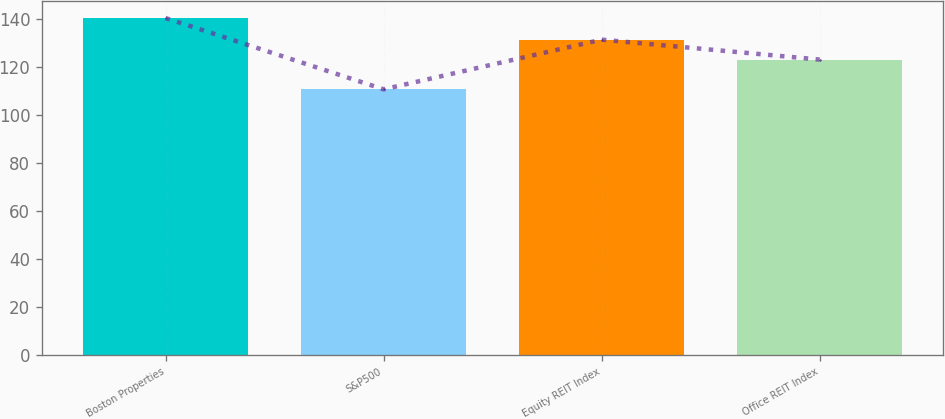Convert chart to OTSL. <chart><loc_0><loc_0><loc_500><loc_500><bar_chart><fcel>Boston Properties<fcel>S&P500<fcel>Equity REIT Index<fcel>Office REIT Index<nl><fcel>140.6<fcel>110.87<fcel>131.58<fcel>123.28<nl></chart> 